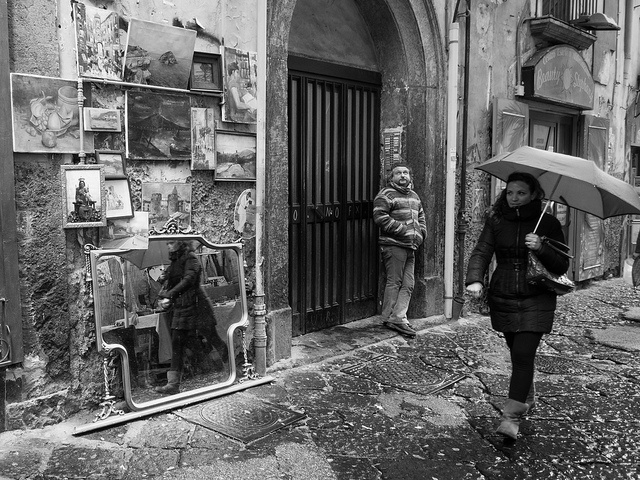Describe the objects in this image and their specific colors. I can see people in gray, black, darkgray, and lightgray tones, umbrella in gray, darkgray, black, and lightgray tones, people in gray, black, darkgray, and lightgray tones, people in gray, black, darkgray, and lightgray tones, and handbag in gray, black, darkgray, and gainsboro tones in this image. 